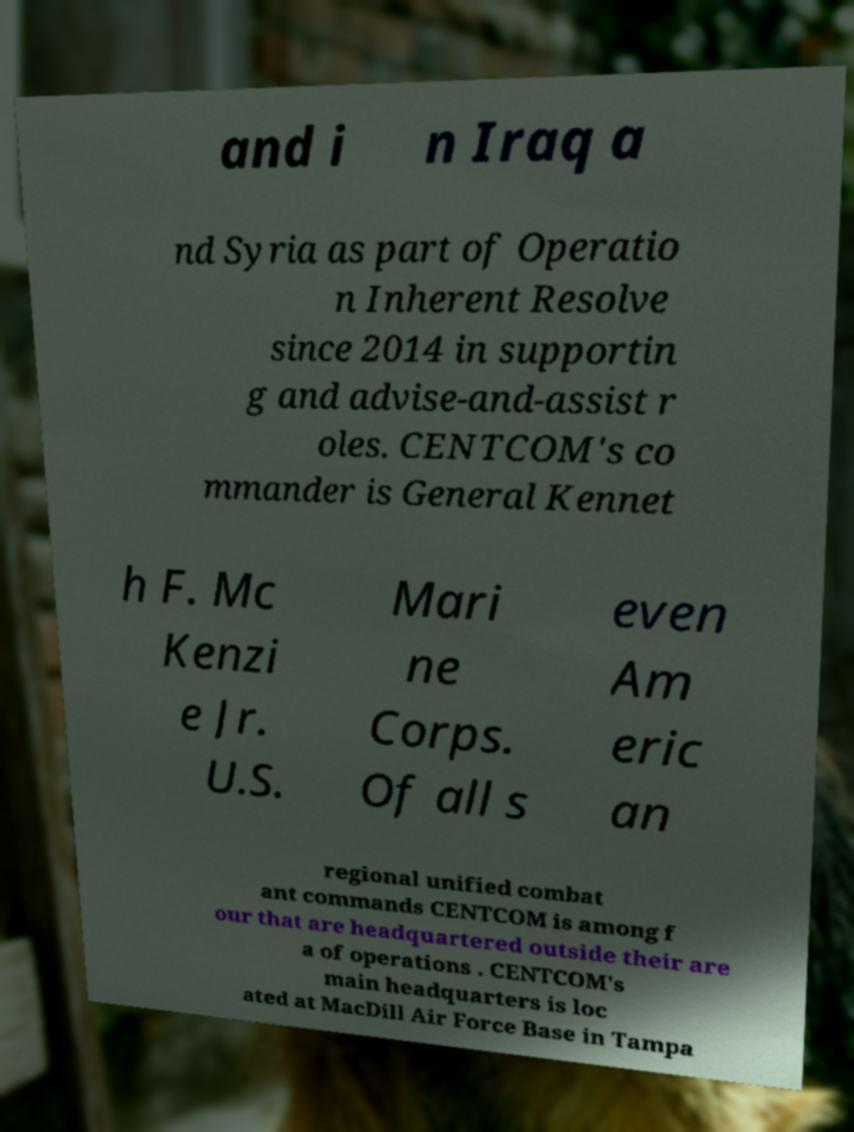Can you read and provide the text displayed in the image?This photo seems to have some interesting text. Can you extract and type it out for me? and i n Iraq a nd Syria as part of Operatio n Inherent Resolve since 2014 in supportin g and advise-and-assist r oles. CENTCOM's co mmander is General Kennet h F. Mc Kenzi e Jr. U.S. Mari ne Corps. Of all s even Am eric an regional unified combat ant commands CENTCOM is among f our that are headquartered outside their are a of operations . CENTCOM's main headquarters is loc ated at MacDill Air Force Base in Tampa 